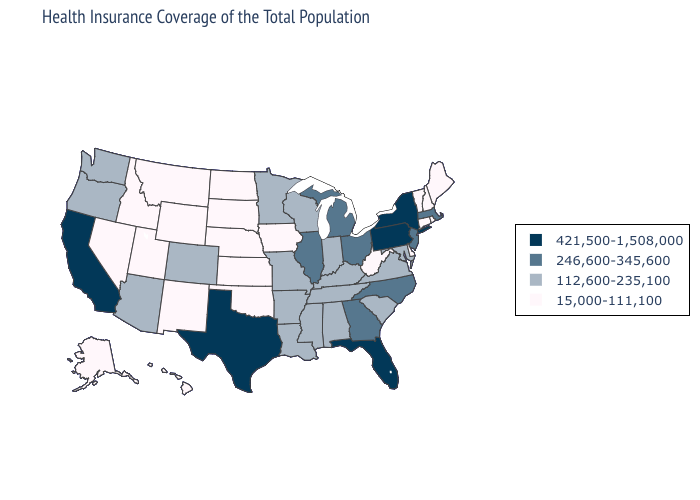Name the states that have a value in the range 421,500-1,508,000?
Concise answer only. California, Florida, New York, Pennsylvania, Texas. Name the states that have a value in the range 421,500-1,508,000?
Concise answer only. California, Florida, New York, Pennsylvania, Texas. Name the states that have a value in the range 421,500-1,508,000?
Quick response, please. California, Florida, New York, Pennsylvania, Texas. What is the lowest value in states that border Arkansas?
Short answer required. 15,000-111,100. Name the states that have a value in the range 112,600-235,100?
Concise answer only. Alabama, Arizona, Arkansas, Colorado, Indiana, Kentucky, Louisiana, Maryland, Minnesota, Mississippi, Missouri, Oregon, South Carolina, Tennessee, Virginia, Washington, Wisconsin. How many symbols are there in the legend?
Write a very short answer. 4. Name the states that have a value in the range 15,000-111,100?
Be succinct. Alaska, Connecticut, Delaware, Hawaii, Idaho, Iowa, Kansas, Maine, Montana, Nebraska, Nevada, New Hampshire, New Mexico, North Dakota, Oklahoma, Rhode Island, South Dakota, Utah, Vermont, West Virginia, Wyoming. Name the states that have a value in the range 246,600-345,600?
Concise answer only. Georgia, Illinois, Massachusetts, Michigan, New Jersey, North Carolina, Ohio. What is the value of South Carolina?
Short answer required. 112,600-235,100. Which states hav the highest value in the MidWest?
Keep it brief. Illinois, Michigan, Ohio. Name the states that have a value in the range 15,000-111,100?
Quick response, please. Alaska, Connecticut, Delaware, Hawaii, Idaho, Iowa, Kansas, Maine, Montana, Nebraska, Nevada, New Hampshire, New Mexico, North Dakota, Oklahoma, Rhode Island, South Dakota, Utah, Vermont, West Virginia, Wyoming. Does Vermont have a lower value than Nebraska?
Write a very short answer. No. What is the value of California?
Answer briefly. 421,500-1,508,000. How many symbols are there in the legend?
Keep it brief. 4. Name the states that have a value in the range 112,600-235,100?
Keep it brief. Alabama, Arizona, Arkansas, Colorado, Indiana, Kentucky, Louisiana, Maryland, Minnesota, Mississippi, Missouri, Oregon, South Carolina, Tennessee, Virginia, Washington, Wisconsin. 